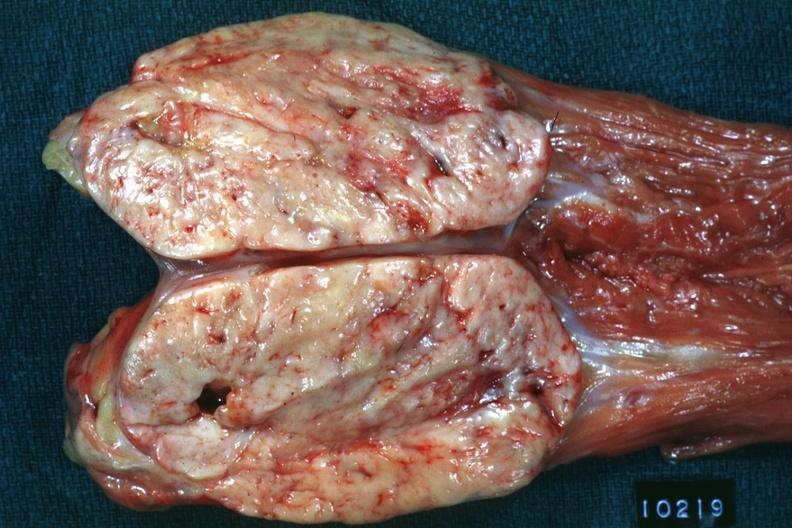what is present?
Answer the question using a single word or phrase. Abdomen 